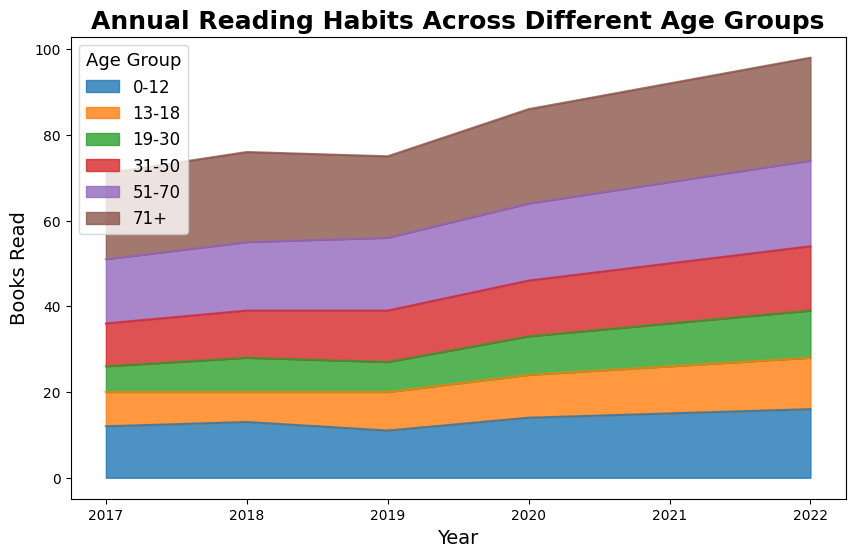Which age group reads the most books overall? Based on the height and color-density of the areas in the chart, the 71+ age group section is consistently the tallest area between 2017 and 2022, indicating the highest total number of books read.
Answer: 71+ Compare the increase in books read by the 0-12 age group from 2017 to 2022. How many more books were read in 2022 than in 2017? In 2017, the 0-12 age group read 12 books. In 2022, they read 16 books. The difference is 16 - 12 = 4 books.
Answer: 4 How did the reading habits of the 13-18 and 19-30 age groups change from 2017 to 2022? From 2017 to 2022, the 13-18 age group increased their reading from 8 to 12 books, while the 19-30 age group increased from 6 to 11 books. Both age groups showed an overall increase in the number of books read.
Answer: Increased for both Which year saw the highest reading average across all age groups? Calculate the average books read per year by adding up the values for all age groups and dividing by the number of age groups. Compare each year:
- 2017: (12+8+6+10+15+20)/6 = 11.83
- 2018: (13+7+8+11+16+21)/6 = 12.67
- 2019: (11+9+7+12+17+19)/6 = 12.5
- 2020: (14+10+9+13+18+22)/6 = 14.33
- 2021: (15+11+10+14+19+23)/6 = 15.33
- 2022: (16+12+11+15+20+24)/6 = 16.33
2022 has the highest average, with 16.33 books per age group.
Answer: 2022 What is the largest single-year increase in reading for any age group, and which group/year does it pertain to? Calculate the year-to-year increase for each age group:
- 0-12: (13-12)=1, (11-13)=-2, (14-11)=3, (15-14)=1, (16-15)=1
- 13-18: (7-8)=-1, (9-7)=2, (10-9)=1, (11-10)=1, (12-11)=1
- 19-30: (8-6)=2, (7-8)=-1, (9-7)=2, (10-9)=1, (11-10)=1
- 31-50: (11-10)=1, (12-11)=1, (13-12)=1, (14-13)=1, (15-14)=1
- 51-70: (16-15)=1, (17-16)=1, (18-17)=1, (19-18)=1, (20-19)=1
- 71+: (21-20)=1, (19-21)=-2, (22-19)=3, (23-22)=1, (24-23)=1
The largest single-year increase is +3 books for the 0-12 group from 2019 to 2020.
Answer: 0-12 (2019-2020) What is the total number of books read by the 31-50 age group over the 6 years? Sum the number of books read by the 31-50 age group from 2017 to 2022:
10 (2017) + 11 (2018) + 12 (2019) + 13 (2020) + 14 (2021) + 15 (2022) = 75 books.
Answer: 75 Which age group shows the least change from year to year in their reading habits? The age group with consistent year-to-year increments or decrements and least variation is 31-50, with each year showing a steady increase of exactly 1 book (10, 11, 12, 13, 14, 15).
Answer: 31-50 